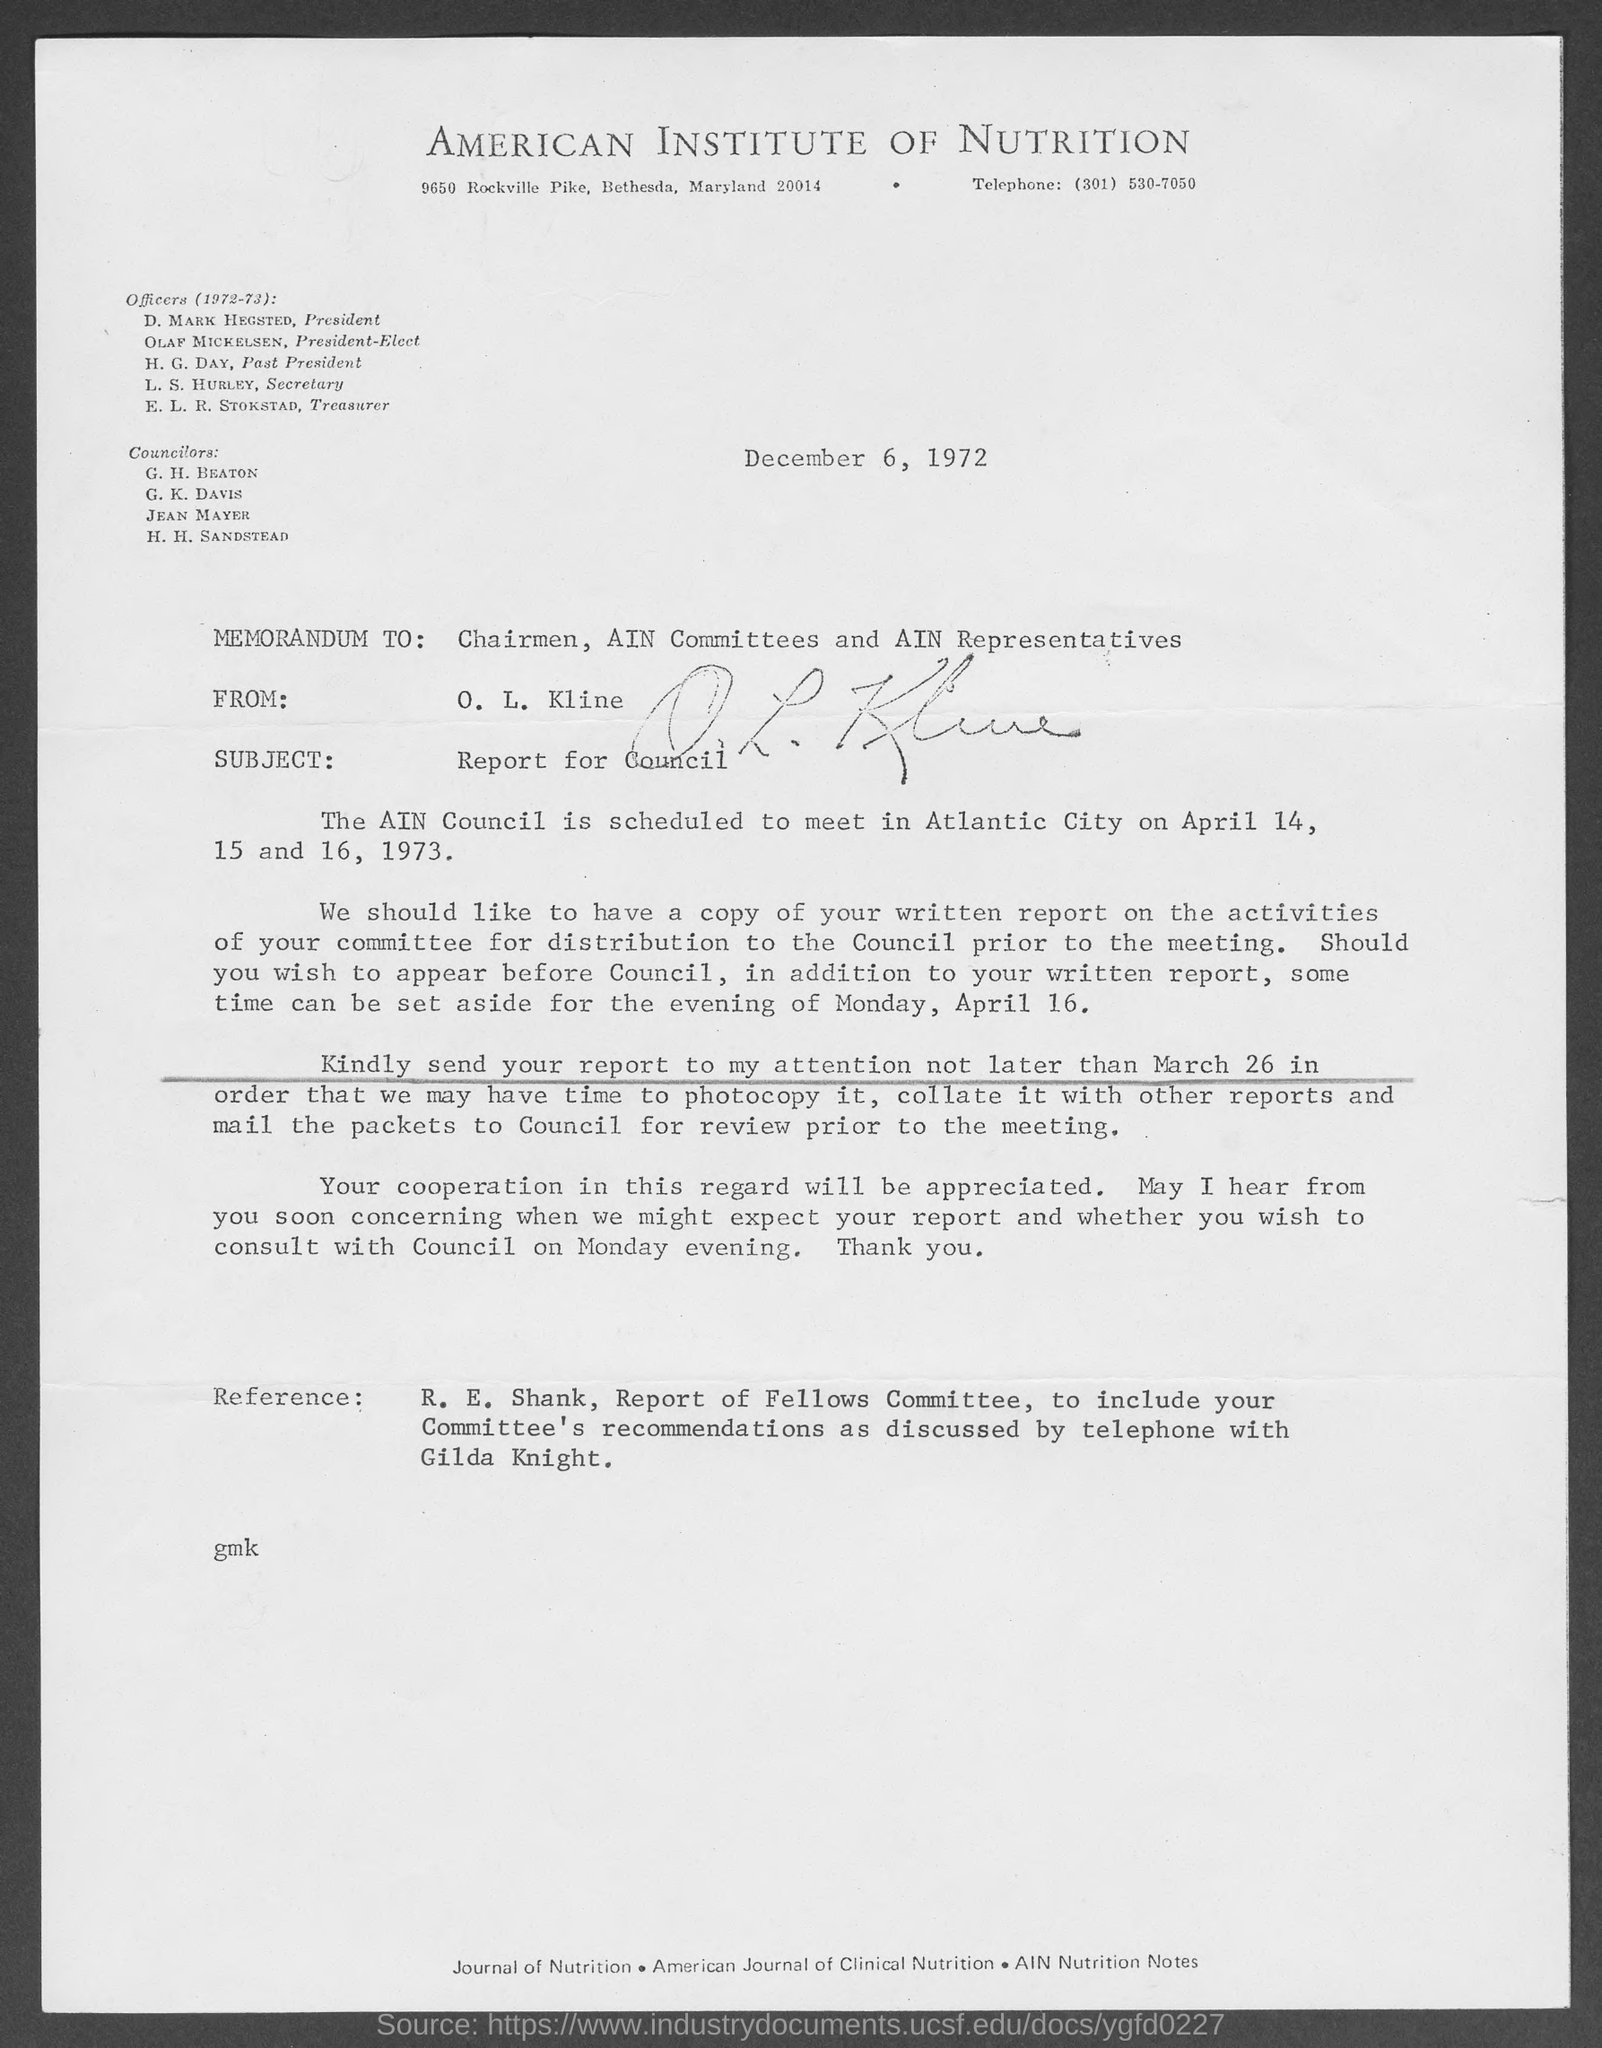What is telephone number of the american institute of nutrition?
Offer a terse response. ( 301) 530-7050. Memorandum is dated on?
Your answer should be very brief. December 6, 1972. Who wrote this memorandum ?
Provide a short and direct response. O. L. Kline. What does ain stand for ?
Your response must be concise. American Institute of Nutrition. Who is  president of the american institute of nutrition?
Provide a short and direct response. D. MARK HEGSTED. Who is the president- elect of the american institute of nutrition?
Give a very brief answer. OLAF MICKELSEN. 